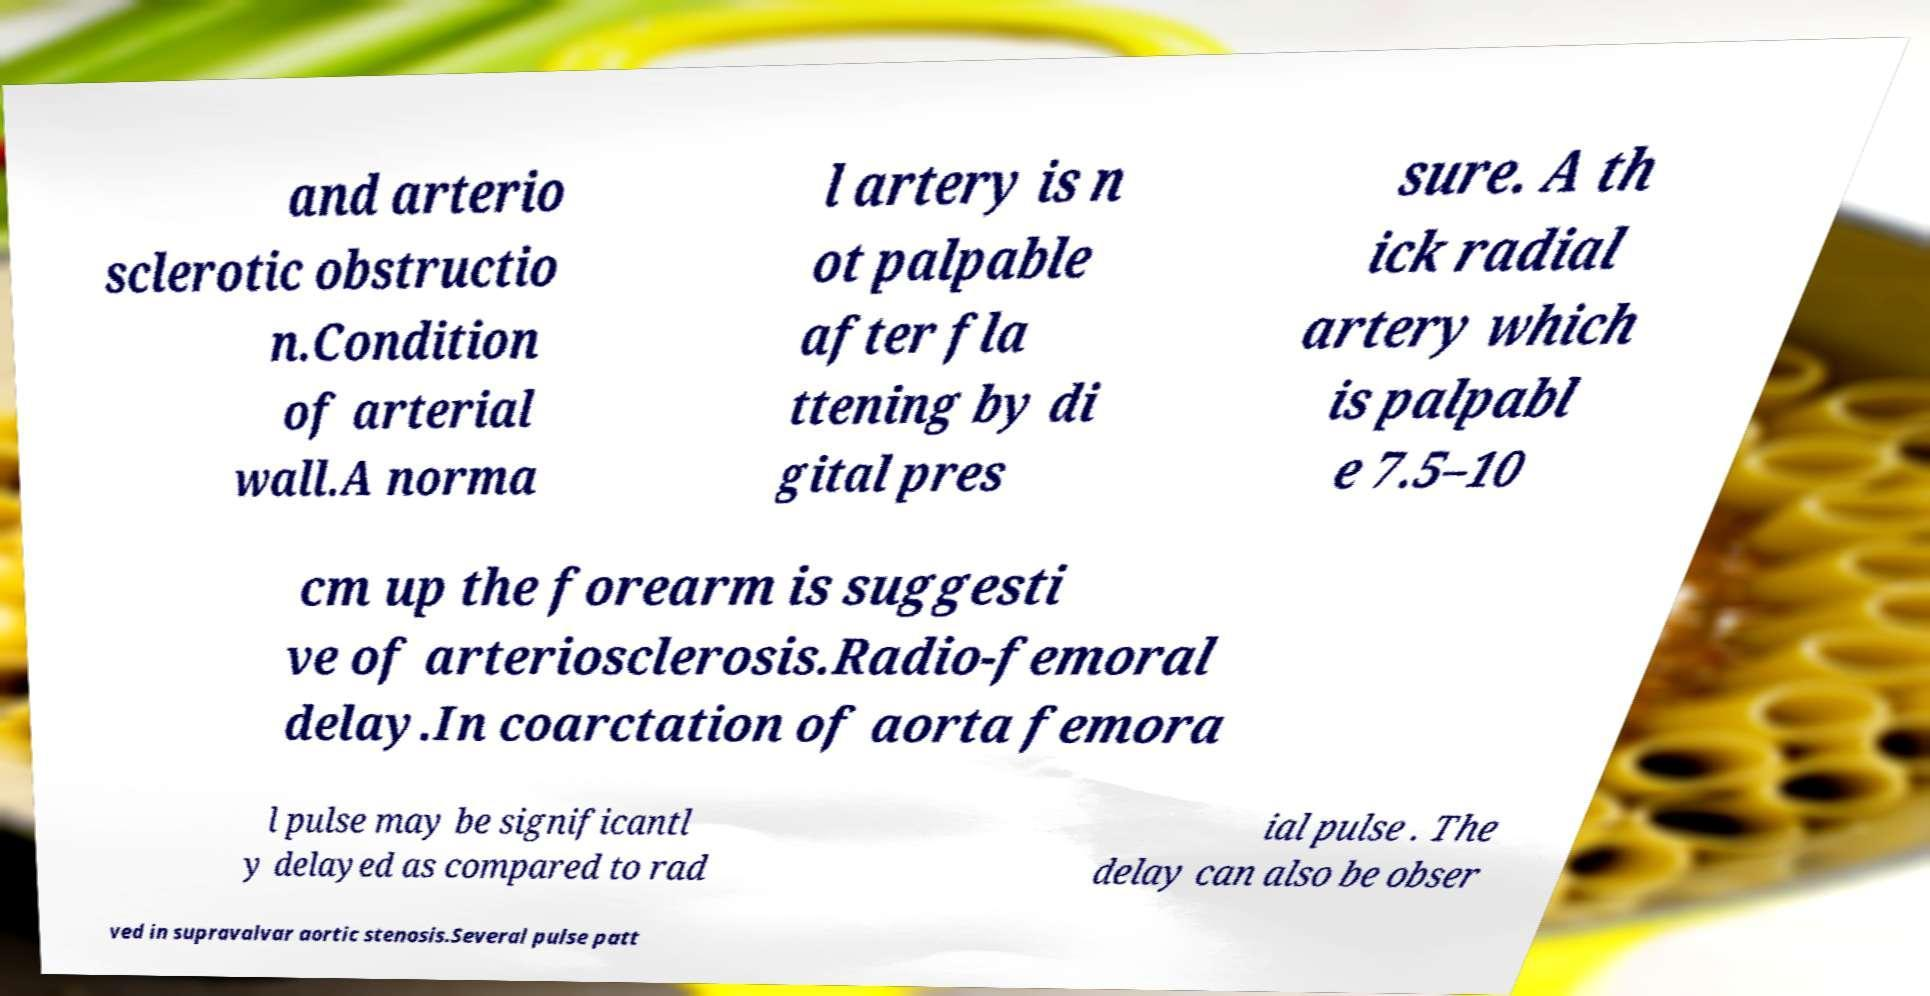Could you assist in decoding the text presented in this image and type it out clearly? and arterio sclerotic obstructio n.Condition of arterial wall.A norma l artery is n ot palpable after fla ttening by di gital pres sure. A th ick radial artery which is palpabl e 7.5–10 cm up the forearm is suggesti ve of arteriosclerosis.Radio-femoral delay.In coarctation of aorta femora l pulse may be significantl y delayed as compared to rad ial pulse . The delay can also be obser ved in supravalvar aortic stenosis.Several pulse patt 